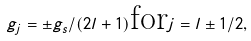Convert formula to latex. <formula><loc_0><loc_0><loc_500><loc_500>g _ { j } = \pm g _ { s } / ( 2 l + 1 ) \text {for} j = l \pm 1 / 2 ,</formula> 